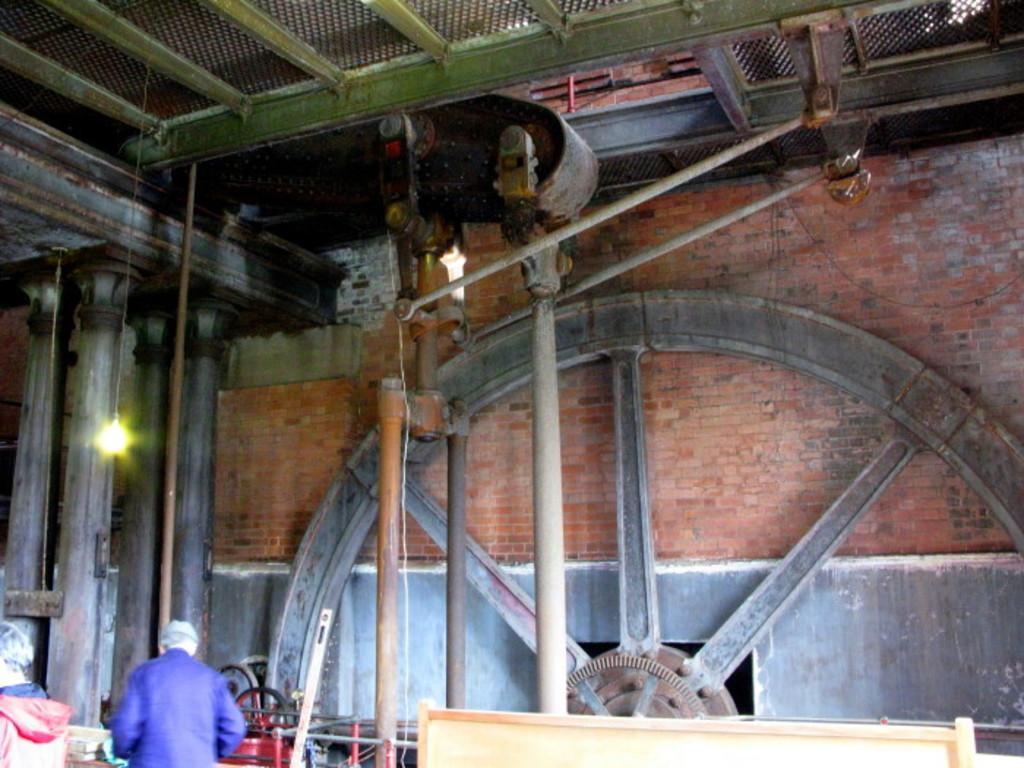How would you summarize this image in a sentence or two? In this image we can see the brick wall, pillars, rods, wheel and also the roof for shelter. We can also see the light hangs from the ceiling. On the left we can see the people and also some other objects. 